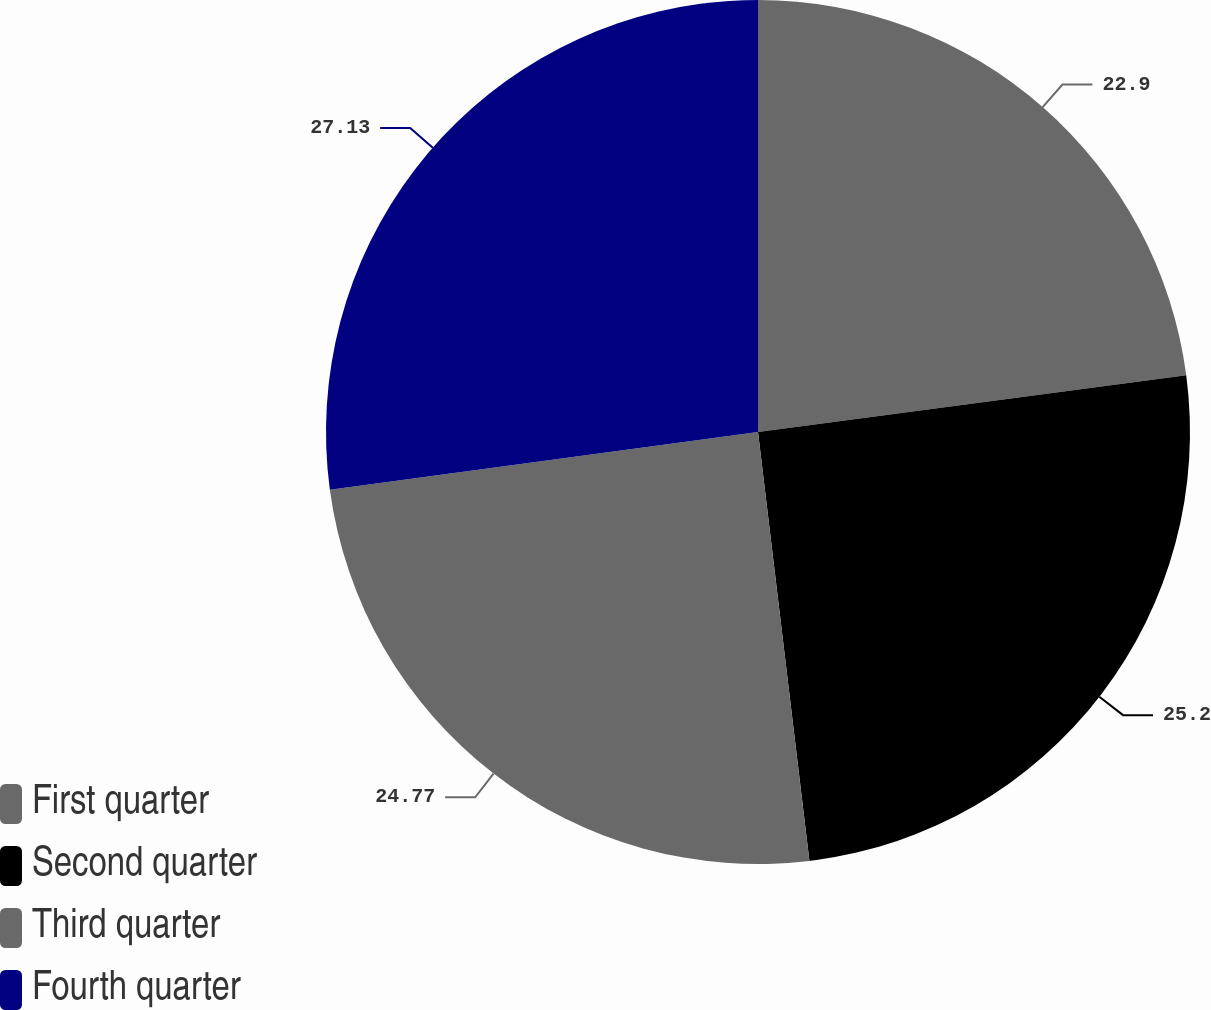Convert chart to OTSL. <chart><loc_0><loc_0><loc_500><loc_500><pie_chart><fcel>First quarter<fcel>Second quarter<fcel>Third quarter<fcel>Fourth quarter<nl><fcel>22.9%<fcel>25.2%<fcel>24.77%<fcel>27.13%<nl></chart> 